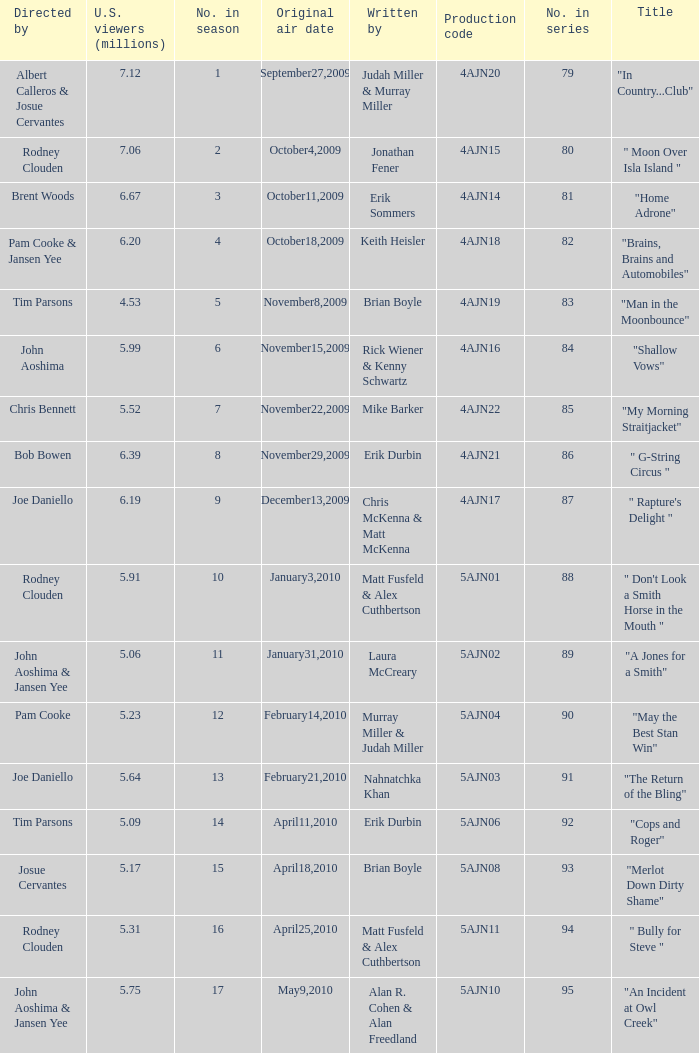Name who wrote number 88 Matt Fusfeld & Alex Cuthbertson. 